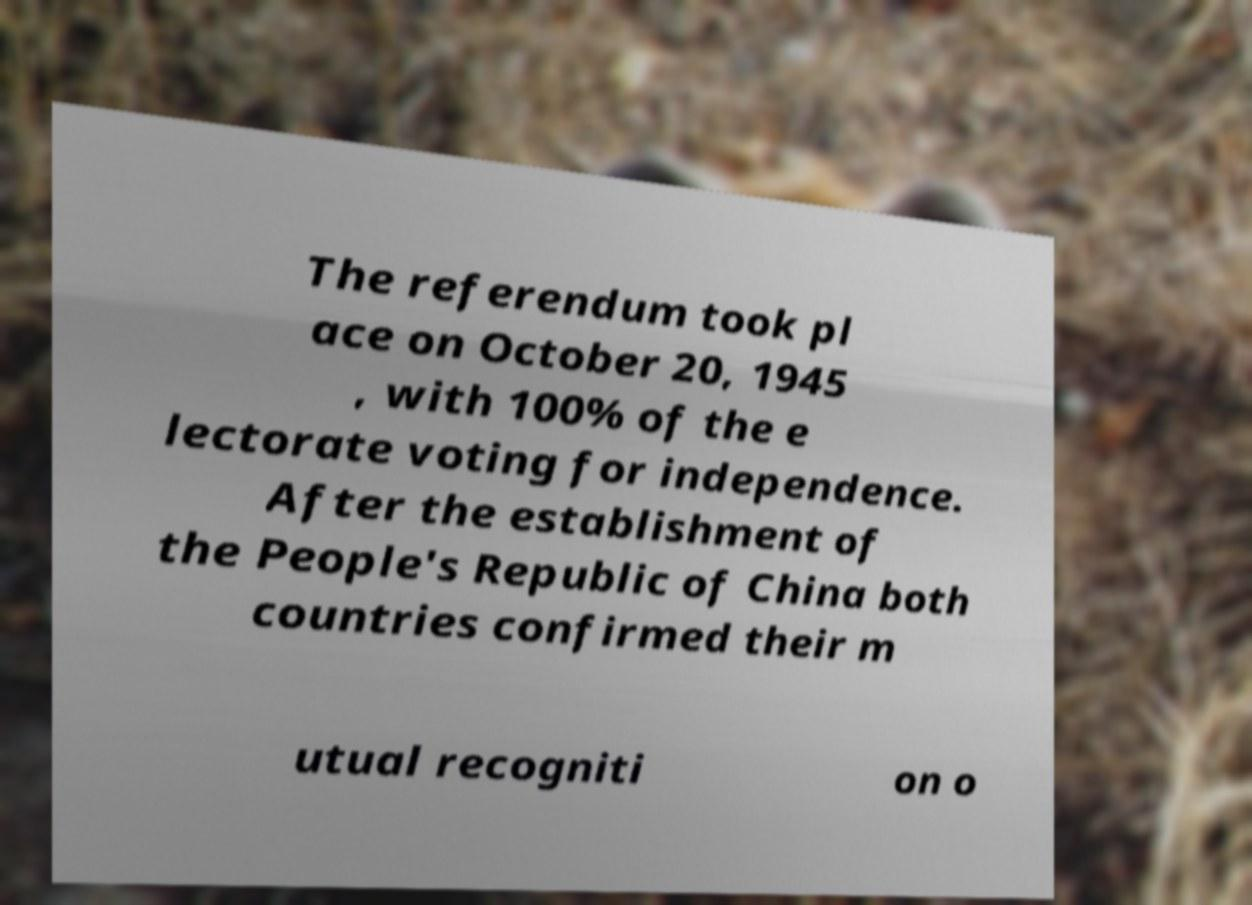Could you assist in decoding the text presented in this image and type it out clearly? The referendum took pl ace on October 20, 1945 , with 100% of the e lectorate voting for independence. After the establishment of the People's Republic of China both countries confirmed their m utual recogniti on o 